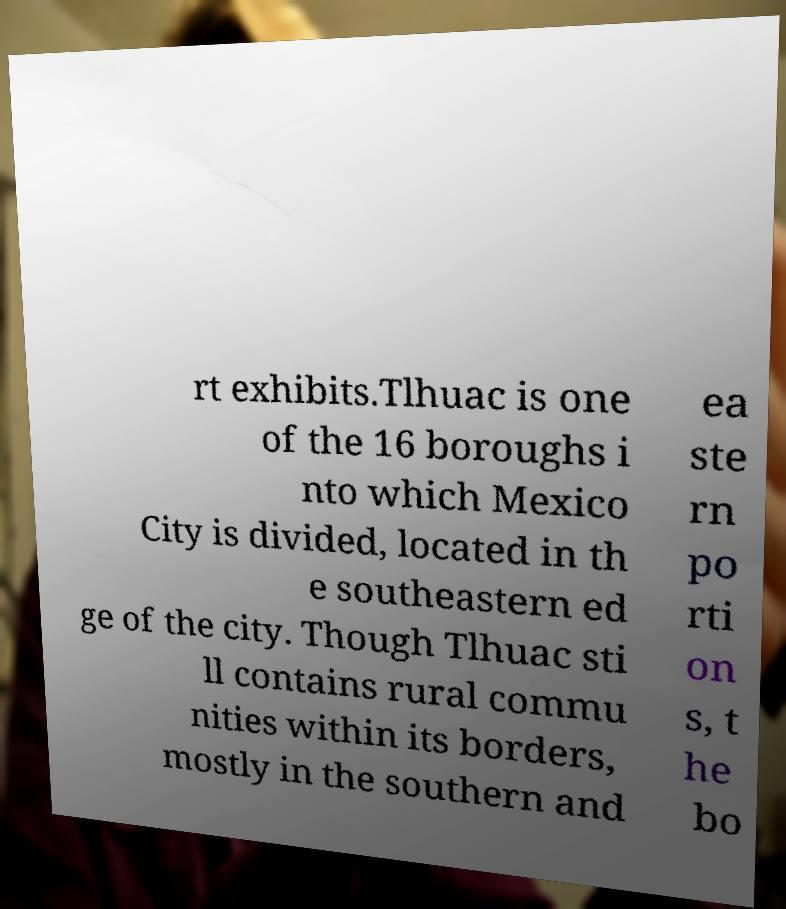There's text embedded in this image that I need extracted. Can you transcribe it verbatim? rt exhibits.Tlhuac is one of the 16 boroughs i nto which Mexico City is divided, located in th e southeastern ed ge of the city. Though Tlhuac sti ll contains rural commu nities within its borders, mostly in the southern and ea ste rn po rti on s, t he bo 